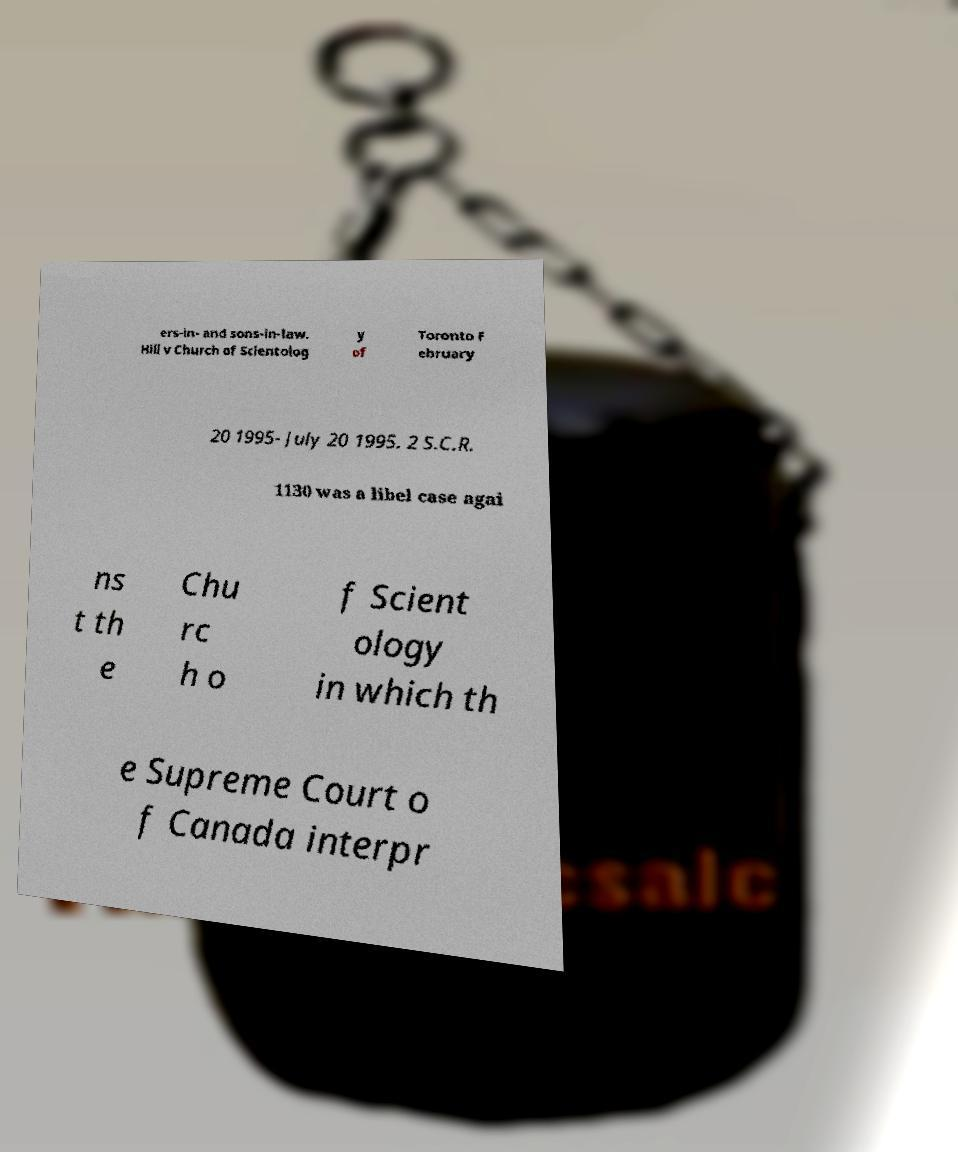Could you extract and type out the text from this image? ers-in- and sons-in-law. Hill v Church of Scientolog y of Toronto F ebruary 20 1995- July 20 1995. 2 S.C.R. 1130 was a libel case agai ns t th e Chu rc h o f Scient ology in which th e Supreme Court o f Canada interpr 